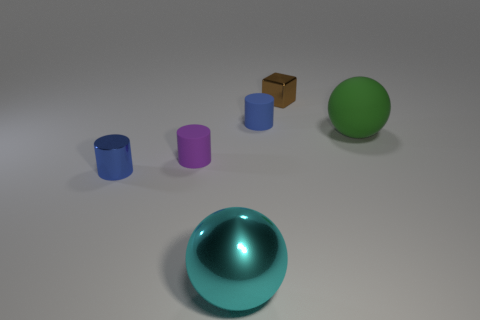There is a purple object that is the same size as the brown object; what material is it?
Offer a very short reply. Rubber. Is the number of tiny blue shiny cylinders that are on the right side of the tiny brown metallic block greater than the number of metallic balls to the right of the large cyan shiny object?
Your answer should be compact. No. Is there a small brown thing that has the same shape as the big metallic thing?
Your response must be concise. No. What shape is the cyan thing that is the same size as the green matte thing?
Ensure brevity in your answer.  Sphere. The rubber object that is behind the rubber ball has what shape?
Provide a succinct answer. Cylinder. Are there fewer matte cylinders that are on the right side of the rubber sphere than small things behind the small blue matte thing?
Provide a succinct answer. Yes. Does the brown metallic cube have the same size as the ball right of the cyan sphere?
Offer a very short reply. No. What number of blue shiny cylinders have the same size as the brown shiny thing?
Your answer should be compact. 1. There is another tiny cylinder that is the same material as the tiny purple cylinder; what is its color?
Your answer should be compact. Blue. Is the number of tiny brown cubes greater than the number of large yellow metal cylinders?
Your response must be concise. Yes. 